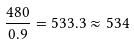<formula> <loc_0><loc_0><loc_500><loc_500>\frac { 4 8 0 } { 0 . 9 } = 5 3 3 . 3 \approx 5 3 4</formula> 